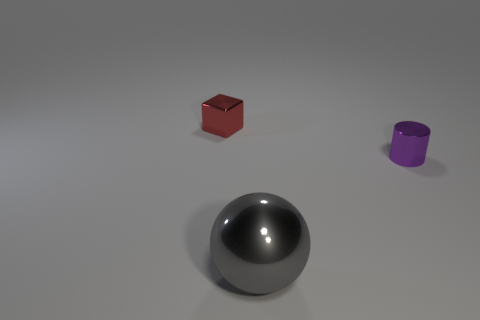Add 1 blocks. How many objects exist? 4 Subtract all blocks. How many objects are left? 2 Add 3 purple cylinders. How many purple cylinders are left? 4 Add 2 gray cubes. How many gray cubes exist? 2 Subtract 0 gray cubes. How many objects are left? 3 Subtract all tiny red things. Subtract all small yellow metallic things. How many objects are left? 2 